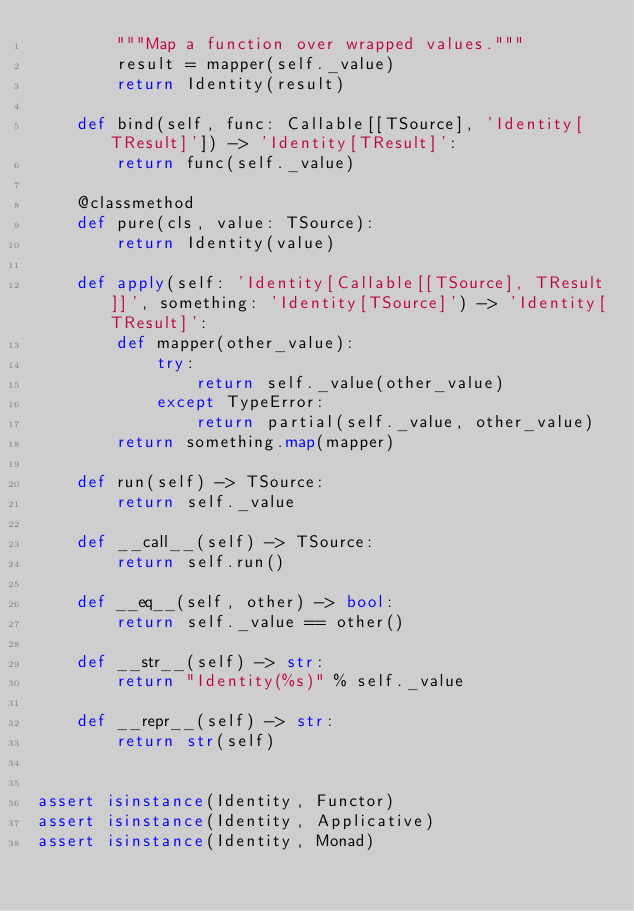Convert code to text. <code><loc_0><loc_0><loc_500><loc_500><_Python_>        """Map a function over wrapped values."""
        result = mapper(self._value)
        return Identity(result)

    def bind(self, func: Callable[[TSource], 'Identity[TResult]']) -> 'Identity[TResult]':
        return func(self._value)

    @classmethod
    def pure(cls, value: TSource):
        return Identity(value)

    def apply(self: 'Identity[Callable[[TSource], TResult]]', something: 'Identity[TSource]') -> 'Identity[TResult]':
        def mapper(other_value):
            try:
                return self._value(other_value)
            except TypeError:
                return partial(self._value, other_value)
        return something.map(mapper)

    def run(self) -> TSource:
        return self._value

    def __call__(self) -> TSource:
        return self.run()

    def __eq__(self, other) -> bool:
        return self._value == other()

    def __str__(self) -> str:
        return "Identity(%s)" % self._value

    def __repr__(self) -> str:
        return str(self)


assert isinstance(Identity, Functor)
assert isinstance(Identity, Applicative)
assert isinstance(Identity, Monad)
</code> 